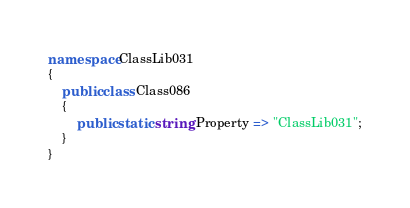Convert code to text. <code><loc_0><loc_0><loc_500><loc_500><_C#_>namespace ClassLib031
{
    public class Class086
    {
        public static string Property => "ClassLib031";
    }
}
</code> 